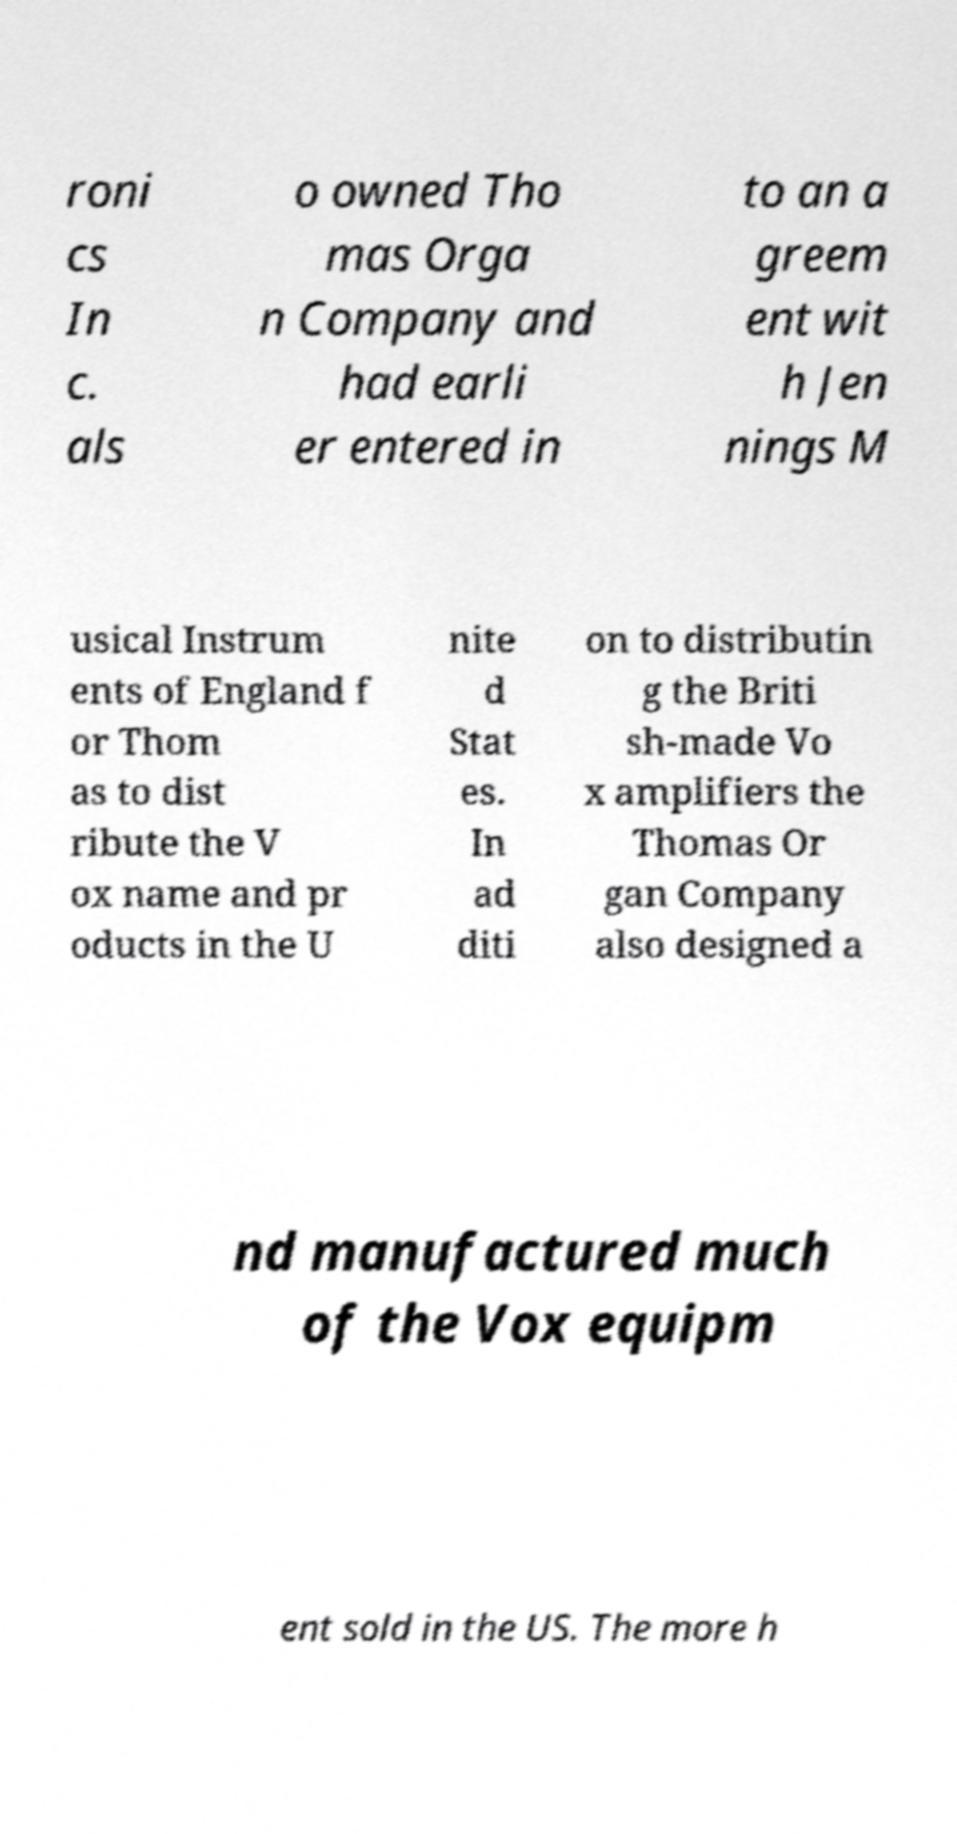For documentation purposes, I need the text within this image transcribed. Could you provide that? roni cs In c. als o owned Tho mas Orga n Company and had earli er entered in to an a greem ent wit h Jen nings M usical Instrum ents of England f or Thom as to dist ribute the V ox name and pr oducts in the U nite d Stat es. In ad diti on to distributin g the Briti sh-made Vo x amplifiers the Thomas Or gan Company also designed a nd manufactured much of the Vox equipm ent sold in the US. The more h 